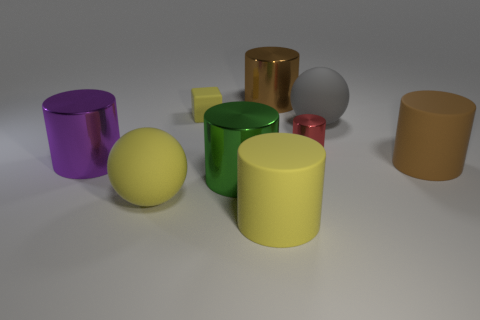Subtract all brown cylinders. How many cylinders are left? 4 Subtract all brown cylinders. How many cylinders are left? 4 Subtract 2 cylinders. How many cylinders are left? 4 Subtract all green cylinders. Subtract all red balls. How many cylinders are left? 5 Add 1 large cyan matte cylinders. How many objects exist? 10 Subtract all cylinders. How many objects are left? 3 Subtract all brown shiny objects. Subtract all big gray spheres. How many objects are left? 7 Add 1 brown matte cylinders. How many brown matte cylinders are left? 2 Add 7 brown rubber cylinders. How many brown rubber cylinders exist? 8 Subtract 0 brown cubes. How many objects are left? 9 